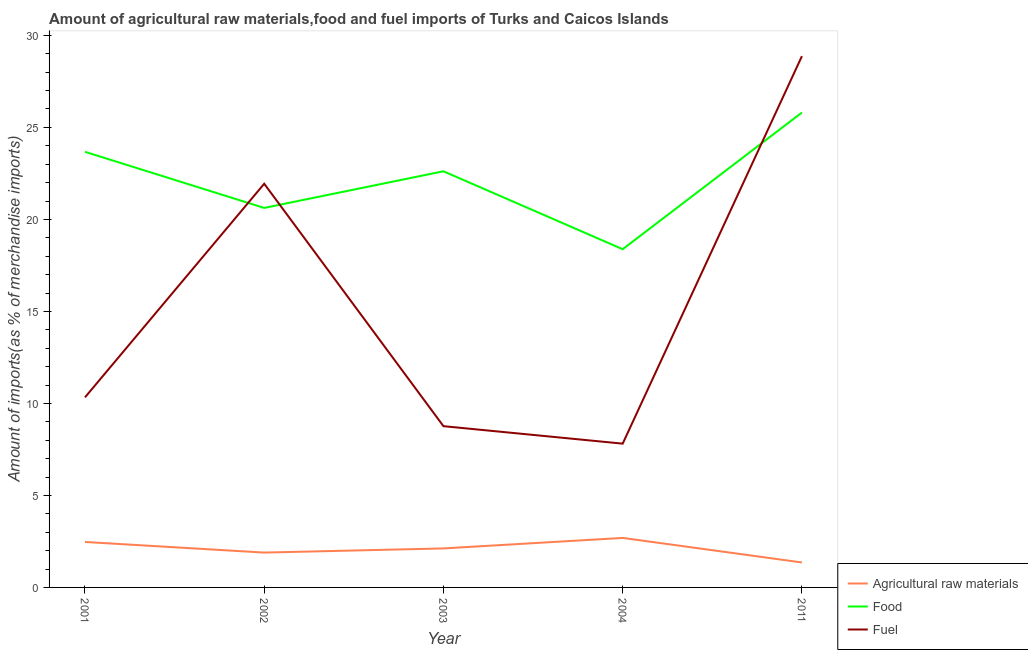What is the percentage of food imports in 2001?
Keep it short and to the point. 23.67. Across all years, what is the maximum percentage of fuel imports?
Keep it short and to the point. 28.87. Across all years, what is the minimum percentage of fuel imports?
Your answer should be compact. 7.81. What is the total percentage of food imports in the graph?
Provide a succinct answer. 111.1. What is the difference between the percentage of raw materials imports in 2002 and that in 2003?
Ensure brevity in your answer.  -0.23. What is the difference between the percentage of fuel imports in 2003 and the percentage of raw materials imports in 2002?
Your response must be concise. 6.87. What is the average percentage of raw materials imports per year?
Keep it short and to the point. 2.11. In the year 2001, what is the difference between the percentage of food imports and percentage of raw materials imports?
Ensure brevity in your answer.  21.2. In how many years, is the percentage of food imports greater than 5 %?
Your answer should be compact. 5. What is the ratio of the percentage of raw materials imports in 2001 to that in 2003?
Make the answer very short. 1.17. Is the percentage of raw materials imports in 2003 less than that in 2004?
Offer a very short reply. Yes. What is the difference between the highest and the second highest percentage of fuel imports?
Give a very brief answer. 6.93. What is the difference between the highest and the lowest percentage of raw materials imports?
Give a very brief answer. 1.33. In how many years, is the percentage of food imports greater than the average percentage of food imports taken over all years?
Ensure brevity in your answer.  3. Is it the case that in every year, the sum of the percentage of raw materials imports and percentage of food imports is greater than the percentage of fuel imports?
Your answer should be compact. No. Does the percentage of food imports monotonically increase over the years?
Keep it short and to the point. No. Is the percentage of food imports strictly greater than the percentage of fuel imports over the years?
Give a very brief answer. No. How many years are there in the graph?
Your answer should be very brief. 5. Are the values on the major ticks of Y-axis written in scientific E-notation?
Offer a very short reply. No. How are the legend labels stacked?
Provide a short and direct response. Vertical. What is the title of the graph?
Make the answer very short. Amount of agricultural raw materials,food and fuel imports of Turks and Caicos Islands. Does "Coal" appear as one of the legend labels in the graph?
Offer a terse response. No. What is the label or title of the Y-axis?
Provide a succinct answer. Amount of imports(as % of merchandise imports). What is the Amount of imports(as % of merchandise imports) of Agricultural raw materials in 2001?
Provide a short and direct response. 2.47. What is the Amount of imports(as % of merchandise imports) of Food in 2001?
Your answer should be very brief. 23.67. What is the Amount of imports(as % of merchandise imports) of Fuel in 2001?
Keep it short and to the point. 10.33. What is the Amount of imports(as % of merchandise imports) of Agricultural raw materials in 2002?
Your answer should be very brief. 1.89. What is the Amount of imports(as % of merchandise imports) of Food in 2002?
Your response must be concise. 20.62. What is the Amount of imports(as % of merchandise imports) in Fuel in 2002?
Offer a very short reply. 21.94. What is the Amount of imports(as % of merchandise imports) of Agricultural raw materials in 2003?
Ensure brevity in your answer.  2.12. What is the Amount of imports(as % of merchandise imports) of Food in 2003?
Your response must be concise. 22.62. What is the Amount of imports(as % of merchandise imports) of Fuel in 2003?
Give a very brief answer. 8.76. What is the Amount of imports(as % of merchandise imports) of Agricultural raw materials in 2004?
Your response must be concise. 2.69. What is the Amount of imports(as % of merchandise imports) in Food in 2004?
Your answer should be compact. 18.38. What is the Amount of imports(as % of merchandise imports) of Fuel in 2004?
Your answer should be very brief. 7.81. What is the Amount of imports(as % of merchandise imports) in Agricultural raw materials in 2011?
Provide a short and direct response. 1.36. What is the Amount of imports(as % of merchandise imports) in Food in 2011?
Offer a very short reply. 25.81. What is the Amount of imports(as % of merchandise imports) of Fuel in 2011?
Your answer should be very brief. 28.87. Across all years, what is the maximum Amount of imports(as % of merchandise imports) of Agricultural raw materials?
Provide a short and direct response. 2.69. Across all years, what is the maximum Amount of imports(as % of merchandise imports) in Food?
Provide a short and direct response. 25.81. Across all years, what is the maximum Amount of imports(as % of merchandise imports) in Fuel?
Your answer should be compact. 28.87. Across all years, what is the minimum Amount of imports(as % of merchandise imports) in Agricultural raw materials?
Give a very brief answer. 1.36. Across all years, what is the minimum Amount of imports(as % of merchandise imports) in Food?
Provide a short and direct response. 18.38. Across all years, what is the minimum Amount of imports(as % of merchandise imports) in Fuel?
Offer a very short reply. 7.81. What is the total Amount of imports(as % of merchandise imports) of Agricultural raw materials in the graph?
Offer a very short reply. 10.53. What is the total Amount of imports(as % of merchandise imports) in Food in the graph?
Ensure brevity in your answer.  111.1. What is the total Amount of imports(as % of merchandise imports) of Fuel in the graph?
Your response must be concise. 77.72. What is the difference between the Amount of imports(as % of merchandise imports) of Agricultural raw materials in 2001 and that in 2002?
Keep it short and to the point. 0.58. What is the difference between the Amount of imports(as % of merchandise imports) of Food in 2001 and that in 2002?
Provide a succinct answer. 3.05. What is the difference between the Amount of imports(as % of merchandise imports) of Fuel in 2001 and that in 2002?
Make the answer very short. -11.61. What is the difference between the Amount of imports(as % of merchandise imports) in Agricultural raw materials in 2001 and that in 2003?
Keep it short and to the point. 0.35. What is the difference between the Amount of imports(as % of merchandise imports) in Food in 2001 and that in 2003?
Offer a terse response. 1.06. What is the difference between the Amount of imports(as % of merchandise imports) in Fuel in 2001 and that in 2003?
Ensure brevity in your answer.  1.57. What is the difference between the Amount of imports(as % of merchandise imports) of Agricultural raw materials in 2001 and that in 2004?
Keep it short and to the point. -0.22. What is the difference between the Amount of imports(as % of merchandise imports) in Food in 2001 and that in 2004?
Your response must be concise. 5.29. What is the difference between the Amount of imports(as % of merchandise imports) of Fuel in 2001 and that in 2004?
Offer a very short reply. 2.52. What is the difference between the Amount of imports(as % of merchandise imports) of Agricultural raw materials in 2001 and that in 2011?
Ensure brevity in your answer.  1.11. What is the difference between the Amount of imports(as % of merchandise imports) in Food in 2001 and that in 2011?
Offer a very short reply. -2.13. What is the difference between the Amount of imports(as % of merchandise imports) of Fuel in 2001 and that in 2011?
Give a very brief answer. -18.54. What is the difference between the Amount of imports(as % of merchandise imports) of Agricultural raw materials in 2002 and that in 2003?
Offer a very short reply. -0.23. What is the difference between the Amount of imports(as % of merchandise imports) in Food in 2002 and that in 2003?
Give a very brief answer. -1.99. What is the difference between the Amount of imports(as % of merchandise imports) in Fuel in 2002 and that in 2003?
Provide a short and direct response. 13.18. What is the difference between the Amount of imports(as % of merchandise imports) in Agricultural raw materials in 2002 and that in 2004?
Your answer should be compact. -0.8. What is the difference between the Amount of imports(as % of merchandise imports) of Food in 2002 and that in 2004?
Provide a short and direct response. 2.24. What is the difference between the Amount of imports(as % of merchandise imports) of Fuel in 2002 and that in 2004?
Provide a succinct answer. 14.13. What is the difference between the Amount of imports(as % of merchandise imports) of Agricultural raw materials in 2002 and that in 2011?
Ensure brevity in your answer.  0.54. What is the difference between the Amount of imports(as % of merchandise imports) of Food in 2002 and that in 2011?
Your response must be concise. -5.18. What is the difference between the Amount of imports(as % of merchandise imports) of Fuel in 2002 and that in 2011?
Your answer should be very brief. -6.93. What is the difference between the Amount of imports(as % of merchandise imports) in Agricultural raw materials in 2003 and that in 2004?
Provide a succinct answer. -0.57. What is the difference between the Amount of imports(as % of merchandise imports) of Food in 2003 and that in 2004?
Offer a very short reply. 4.23. What is the difference between the Amount of imports(as % of merchandise imports) in Fuel in 2003 and that in 2004?
Make the answer very short. 0.95. What is the difference between the Amount of imports(as % of merchandise imports) in Agricultural raw materials in 2003 and that in 2011?
Your answer should be very brief. 0.76. What is the difference between the Amount of imports(as % of merchandise imports) of Food in 2003 and that in 2011?
Keep it short and to the point. -3.19. What is the difference between the Amount of imports(as % of merchandise imports) in Fuel in 2003 and that in 2011?
Keep it short and to the point. -20.11. What is the difference between the Amount of imports(as % of merchandise imports) of Agricultural raw materials in 2004 and that in 2011?
Provide a short and direct response. 1.33. What is the difference between the Amount of imports(as % of merchandise imports) in Food in 2004 and that in 2011?
Offer a terse response. -7.43. What is the difference between the Amount of imports(as % of merchandise imports) of Fuel in 2004 and that in 2011?
Your answer should be very brief. -21.06. What is the difference between the Amount of imports(as % of merchandise imports) in Agricultural raw materials in 2001 and the Amount of imports(as % of merchandise imports) in Food in 2002?
Offer a terse response. -18.15. What is the difference between the Amount of imports(as % of merchandise imports) in Agricultural raw materials in 2001 and the Amount of imports(as % of merchandise imports) in Fuel in 2002?
Your response must be concise. -19.47. What is the difference between the Amount of imports(as % of merchandise imports) in Food in 2001 and the Amount of imports(as % of merchandise imports) in Fuel in 2002?
Ensure brevity in your answer.  1.73. What is the difference between the Amount of imports(as % of merchandise imports) of Agricultural raw materials in 2001 and the Amount of imports(as % of merchandise imports) of Food in 2003?
Provide a succinct answer. -20.14. What is the difference between the Amount of imports(as % of merchandise imports) of Agricultural raw materials in 2001 and the Amount of imports(as % of merchandise imports) of Fuel in 2003?
Your response must be concise. -6.29. What is the difference between the Amount of imports(as % of merchandise imports) in Food in 2001 and the Amount of imports(as % of merchandise imports) in Fuel in 2003?
Your answer should be very brief. 14.91. What is the difference between the Amount of imports(as % of merchandise imports) of Agricultural raw materials in 2001 and the Amount of imports(as % of merchandise imports) of Food in 2004?
Provide a short and direct response. -15.91. What is the difference between the Amount of imports(as % of merchandise imports) of Agricultural raw materials in 2001 and the Amount of imports(as % of merchandise imports) of Fuel in 2004?
Make the answer very short. -5.34. What is the difference between the Amount of imports(as % of merchandise imports) of Food in 2001 and the Amount of imports(as % of merchandise imports) of Fuel in 2004?
Make the answer very short. 15.86. What is the difference between the Amount of imports(as % of merchandise imports) in Agricultural raw materials in 2001 and the Amount of imports(as % of merchandise imports) in Food in 2011?
Your answer should be very brief. -23.34. What is the difference between the Amount of imports(as % of merchandise imports) in Agricultural raw materials in 2001 and the Amount of imports(as % of merchandise imports) in Fuel in 2011?
Your answer should be very brief. -26.4. What is the difference between the Amount of imports(as % of merchandise imports) of Food in 2001 and the Amount of imports(as % of merchandise imports) of Fuel in 2011?
Provide a short and direct response. -5.2. What is the difference between the Amount of imports(as % of merchandise imports) in Agricultural raw materials in 2002 and the Amount of imports(as % of merchandise imports) in Food in 2003?
Offer a terse response. -20.72. What is the difference between the Amount of imports(as % of merchandise imports) of Agricultural raw materials in 2002 and the Amount of imports(as % of merchandise imports) of Fuel in 2003?
Offer a very short reply. -6.87. What is the difference between the Amount of imports(as % of merchandise imports) in Food in 2002 and the Amount of imports(as % of merchandise imports) in Fuel in 2003?
Give a very brief answer. 11.86. What is the difference between the Amount of imports(as % of merchandise imports) in Agricultural raw materials in 2002 and the Amount of imports(as % of merchandise imports) in Food in 2004?
Offer a very short reply. -16.49. What is the difference between the Amount of imports(as % of merchandise imports) of Agricultural raw materials in 2002 and the Amount of imports(as % of merchandise imports) of Fuel in 2004?
Offer a very short reply. -5.92. What is the difference between the Amount of imports(as % of merchandise imports) of Food in 2002 and the Amount of imports(as % of merchandise imports) of Fuel in 2004?
Provide a short and direct response. 12.81. What is the difference between the Amount of imports(as % of merchandise imports) of Agricultural raw materials in 2002 and the Amount of imports(as % of merchandise imports) of Food in 2011?
Your answer should be compact. -23.91. What is the difference between the Amount of imports(as % of merchandise imports) of Agricultural raw materials in 2002 and the Amount of imports(as % of merchandise imports) of Fuel in 2011?
Offer a terse response. -26.98. What is the difference between the Amount of imports(as % of merchandise imports) in Food in 2002 and the Amount of imports(as % of merchandise imports) in Fuel in 2011?
Provide a succinct answer. -8.25. What is the difference between the Amount of imports(as % of merchandise imports) of Agricultural raw materials in 2003 and the Amount of imports(as % of merchandise imports) of Food in 2004?
Offer a very short reply. -16.26. What is the difference between the Amount of imports(as % of merchandise imports) of Agricultural raw materials in 2003 and the Amount of imports(as % of merchandise imports) of Fuel in 2004?
Make the answer very short. -5.69. What is the difference between the Amount of imports(as % of merchandise imports) in Food in 2003 and the Amount of imports(as % of merchandise imports) in Fuel in 2004?
Your answer should be very brief. 14.8. What is the difference between the Amount of imports(as % of merchandise imports) in Agricultural raw materials in 2003 and the Amount of imports(as % of merchandise imports) in Food in 2011?
Make the answer very short. -23.69. What is the difference between the Amount of imports(as % of merchandise imports) in Agricultural raw materials in 2003 and the Amount of imports(as % of merchandise imports) in Fuel in 2011?
Provide a succinct answer. -26.75. What is the difference between the Amount of imports(as % of merchandise imports) of Food in 2003 and the Amount of imports(as % of merchandise imports) of Fuel in 2011?
Your answer should be very brief. -6.26. What is the difference between the Amount of imports(as % of merchandise imports) of Agricultural raw materials in 2004 and the Amount of imports(as % of merchandise imports) of Food in 2011?
Keep it short and to the point. -23.12. What is the difference between the Amount of imports(as % of merchandise imports) in Agricultural raw materials in 2004 and the Amount of imports(as % of merchandise imports) in Fuel in 2011?
Make the answer very short. -26.18. What is the difference between the Amount of imports(as % of merchandise imports) of Food in 2004 and the Amount of imports(as % of merchandise imports) of Fuel in 2011?
Your answer should be compact. -10.49. What is the average Amount of imports(as % of merchandise imports) in Agricultural raw materials per year?
Your answer should be very brief. 2.11. What is the average Amount of imports(as % of merchandise imports) of Food per year?
Provide a succinct answer. 22.22. What is the average Amount of imports(as % of merchandise imports) of Fuel per year?
Your answer should be very brief. 15.54. In the year 2001, what is the difference between the Amount of imports(as % of merchandise imports) of Agricultural raw materials and Amount of imports(as % of merchandise imports) of Food?
Give a very brief answer. -21.2. In the year 2001, what is the difference between the Amount of imports(as % of merchandise imports) of Agricultural raw materials and Amount of imports(as % of merchandise imports) of Fuel?
Give a very brief answer. -7.86. In the year 2001, what is the difference between the Amount of imports(as % of merchandise imports) in Food and Amount of imports(as % of merchandise imports) in Fuel?
Provide a short and direct response. 13.34. In the year 2002, what is the difference between the Amount of imports(as % of merchandise imports) in Agricultural raw materials and Amount of imports(as % of merchandise imports) in Food?
Offer a very short reply. -18.73. In the year 2002, what is the difference between the Amount of imports(as % of merchandise imports) of Agricultural raw materials and Amount of imports(as % of merchandise imports) of Fuel?
Your answer should be compact. -20.04. In the year 2002, what is the difference between the Amount of imports(as % of merchandise imports) of Food and Amount of imports(as % of merchandise imports) of Fuel?
Ensure brevity in your answer.  -1.31. In the year 2003, what is the difference between the Amount of imports(as % of merchandise imports) of Agricultural raw materials and Amount of imports(as % of merchandise imports) of Food?
Provide a succinct answer. -20.5. In the year 2003, what is the difference between the Amount of imports(as % of merchandise imports) in Agricultural raw materials and Amount of imports(as % of merchandise imports) in Fuel?
Your answer should be compact. -6.64. In the year 2003, what is the difference between the Amount of imports(as % of merchandise imports) of Food and Amount of imports(as % of merchandise imports) of Fuel?
Make the answer very short. 13.85. In the year 2004, what is the difference between the Amount of imports(as % of merchandise imports) of Agricultural raw materials and Amount of imports(as % of merchandise imports) of Food?
Make the answer very short. -15.69. In the year 2004, what is the difference between the Amount of imports(as % of merchandise imports) in Agricultural raw materials and Amount of imports(as % of merchandise imports) in Fuel?
Offer a very short reply. -5.12. In the year 2004, what is the difference between the Amount of imports(as % of merchandise imports) of Food and Amount of imports(as % of merchandise imports) of Fuel?
Keep it short and to the point. 10.57. In the year 2011, what is the difference between the Amount of imports(as % of merchandise imports) of Agricultural raw materials and Amount of imports(as % of merchandise imports) of Food?
Offer a terse response. -24.45. In the year 2011, what is the difference between the Amount of imports(as % of merchandise imports) in Agricultural raw materials and Amount of imports(as % of merchandise imports) in Fuel?
Ensure brevity in your answer.  -27.52. In the year 2011, what is the difference between the Amount of imports(as % of merchandise imports) of Food and Amount of imports(as % of merchandise imports) of Fuel?
Your answer should be very brief. -3.06. What is the ratio of the Amount of imports(as % of merchandise imports) in Agricultural raw materials in 2001 to that in 2002?
Provide a short and direct response. 1.3. What is the ratio of the Amount of imports(as % of merchandise imports) of Food in 2001 to that in 2002?
Offer a very short reply. 1.15. What is the ratio of the Amount of imports(as % of merchandise imports) of Fuel in 2001 to that in 2002?
Your response must be concise. 0.47. What is the ratio of the Amount of imports(as % of merchandise imports) of Agricultural raw materials in 2001 to that in 2003?
Ensure brevity in your answer.  1.17. What is the ratio of the Amount of imports(as % of merchandise imports) of Food in 2001 to that in 2003?
Your response must be concise. 1.05. What is the ratio of the Amount of imports(as % of merchandise imports) in Fuel in 2001 to that in 2003?
Keep it short and to the point. 1.18. What is the ratio of the Amount of imports(as % of merchandise imports) of Agricultural raw materials in 2001 to that in 2004?
Offer a terse response. 0.92. What is the ratio of the Amount of imports(as % of merchandise imports) in Food in 2001 to that in 2004?
Offer a terse response. 1.29. What is the ratio of the Amount of imports(as % of merchandise imports) in Fuel in 2001 to that in 2004?
Provide a succinct answer. 1.32. What is the ratio of the Amount of imports(as % of merchandise imports) in Agricultural raw materials in 2001 to that in 2011?
Provide a short and direct response. 1.82. What is the ratio of the Amount of imports(as % of merchandise imports) of Food in 2001 to that in 2011?
Provide a succinct answer. 0.92. What is the ratio of the Amount of imports(as % of merchandise imports) of Fuel in 2001 to that in 2011?
Give a very brief answer. 0.36. What is the ratio of the Amount of imports(as % of merchandise imports) in Agricultural raw materials in 2002 to that in 2003?
Your response must be concise. 0.89. What is the ratio of the Amount of imports(as % of merchandise imports) in Food in 2002 to that in 2003?
Ensure brevity in your answer.  0.91. What is the ratio of the Amount of imports(as % of merchandise imports) in Fuel in 2002 to that in 2003?
Offer a terse response. 2.5. What is the ratio of the Amount of imports(as % of merchandise imports) of Agricultural raw materials in 2002 to that in 2004?
Ensure brevity in your answer.  0.7. What is the ratio of the Amount of imports(as % of merchandise imports) of Food in 2002 to that in 2004?
Your answer should be compact. 1.12. What is the ratio of the Amount of imports(as % of merchandise imports) of Fuel in 2002 to that in 2004?
Your response must be concise. 2.81. What is the ratio of the Amount of imports(as % of merchandise imports) in Agricultural raw materials in 2002 to that in 2011?
Provide a short and direct response. 1.4. What is the ratio of the Amount of imports(as % of merchandise imports) in Food in 2002 to that in 2011?
Your answer should be compact. 0.8. What is the ratio of the Amount of imports(as % of merchandise imports) of Fuel in 2002 to that in 2011?
Your answer should be compact. 0.76. What is the ratio of the Amount of imports(as % of merchandise imports) of Agricultural raw materials in 2003 to that in 2004?
Keep it short and to the point. 0.79. What is the ratio of the Amount of imports(as % of merchandise imports) in Food in 2003 to that in 2004?
Offer a terse response. 1.23. What is the ratio of the Amount of imports(as % of merchandise imports) of Fuel in 2003 to that in 2004?
Your response must be concise. 1.12. What is the ratio of the Amount of imports(as % of merchandise imports) of Agricultural raw materials in 2003 to that in 2011?
Offer a terse response. 1.56. What is the ratio of the Amount of imports(as % of merchandise imports) in Food in 2003 to that in 2011?
Your answer should be very brief. 0.88. What is the ratio of the Amount of imports(as % of merchandise imports) in Fuel in 2003 to that in 2011?
Give a very brief answer. 0.3. What is the ratio of the Amount of imports(as % of merchandise imports) in Agricultural raw materials in 2004 to that in 2011?
Give a very brief answer. 1.98. What is the ratio of the Amount of imports(as % of merchandise imports) of Food in 2004 to that in 2011?
Your answer should be compact. 0.71. What is the ratio of the Amount of imports(as % of merchandise imports) of Fuel in 2004 to that in 2011?
Provide a short and direct response. 0.27. What is the difference between the highest and the second highest Amount of imports(as % of merchandise imports) in Agricultural raw materials?
Give a very brief answer. 0.22. What is the difference between the highest and the second highest Amount of imports(as % of merchandise imports) in Food?
Provide a short and direct response. 2.13. What is the difference between the highest and the second highest Amount of imports(as % of merchandise imports) of Fuel?
Provide a succinct answer. 6.93. What is the difference between the highest and the lowest Amount of imports(as % of merchandise imports) of Agricultural raw materials?
Offer a terse response. 1.33. What is the difference between the highest and the lowest Amount of imports(as % of merchandise imports) in Food?
Make the answer very short. 7.43. What is the difference between the highest and the lowest Amount of imports(as % of merchandise imports) in Fuel?
Offer a terse response. 21.06. 